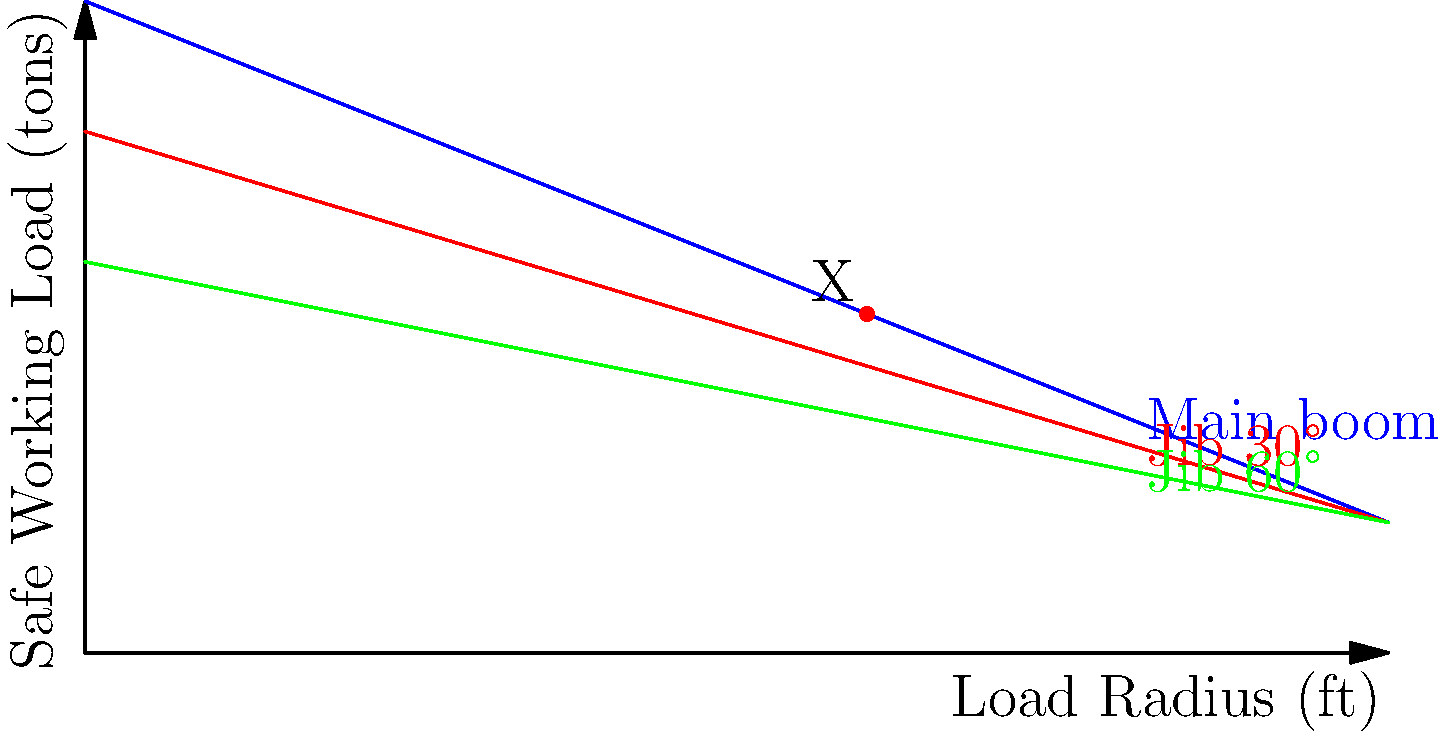Based on the crane load chart provided, what is the maximum safe working load (in tons) that can be lifted at a radius of 60 feet using the jib at a 30° angle? To determine the maximum safe working load at a radius of 60 feet using the jib at a 30° angle, we need to follow these steps:

1. Locate the curve representing the jib at 30° (red line) on the load chart.
2. Find the point on this curve that corresponds to a radius of 60 feet on the x-axis.
3. Read the corresponding value on the y-axis (Safe Working Load).

From the chart, we can see that:

1. The red line represents the jib at 30°.
2. At x = 60 ft (radius), we find point X on the red curve.
3. The y-coordinate of point X is approximately 22 tons.

Therefore, the maximum safe working load at a radius of 60 feet using the jib at a 30° angle is 22 tons.

It's important to note that this chart is a simplified representation for educational purposes. In real-world scenarios, crane operators and site managers would use more detailed load charts specific to their equipment and consider additional factors such as wind speed, ground conditions, and the specific configuration of the crane.
Answer: 22 tons 